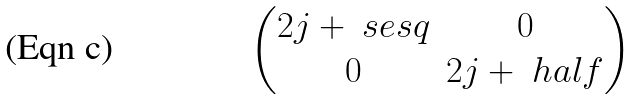<formula> <loc_0><loc_0><loc_500><loc_500>\begin{pmatrix} 2 j + \ s e s q & 0 \\ 0 & 2 j + \ h a l f \end{pmatrix}</formula> 